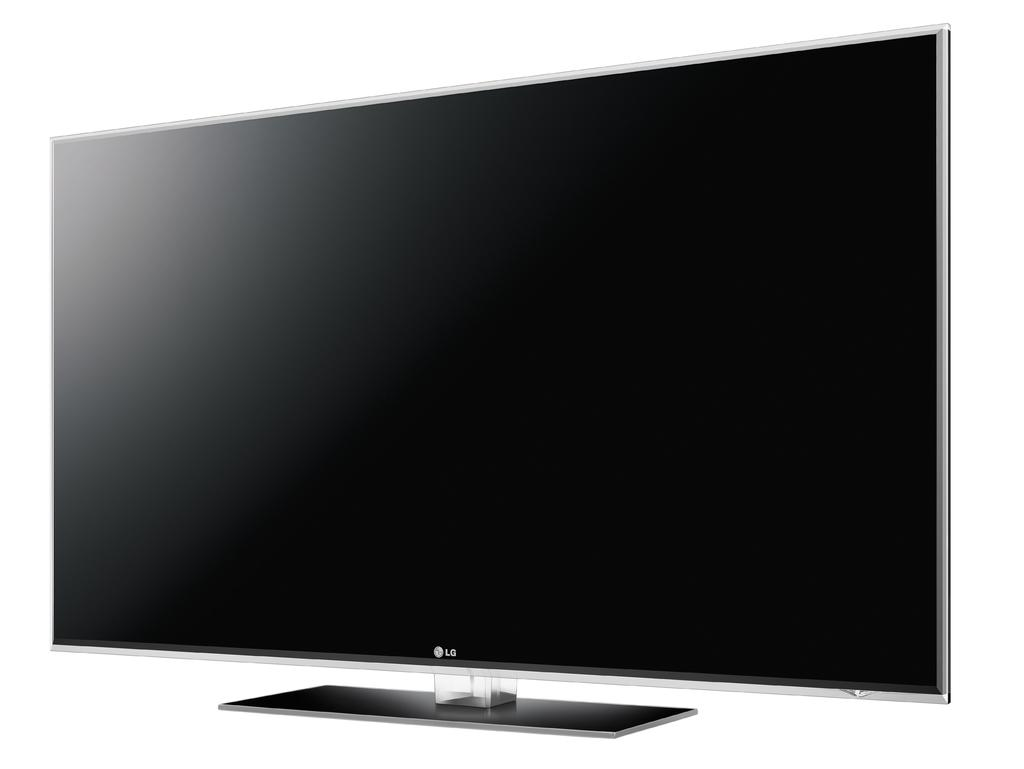<image>
Offer a succinct explanation of the picture presented. An unpowered Lg branded television with a white background behind it. 